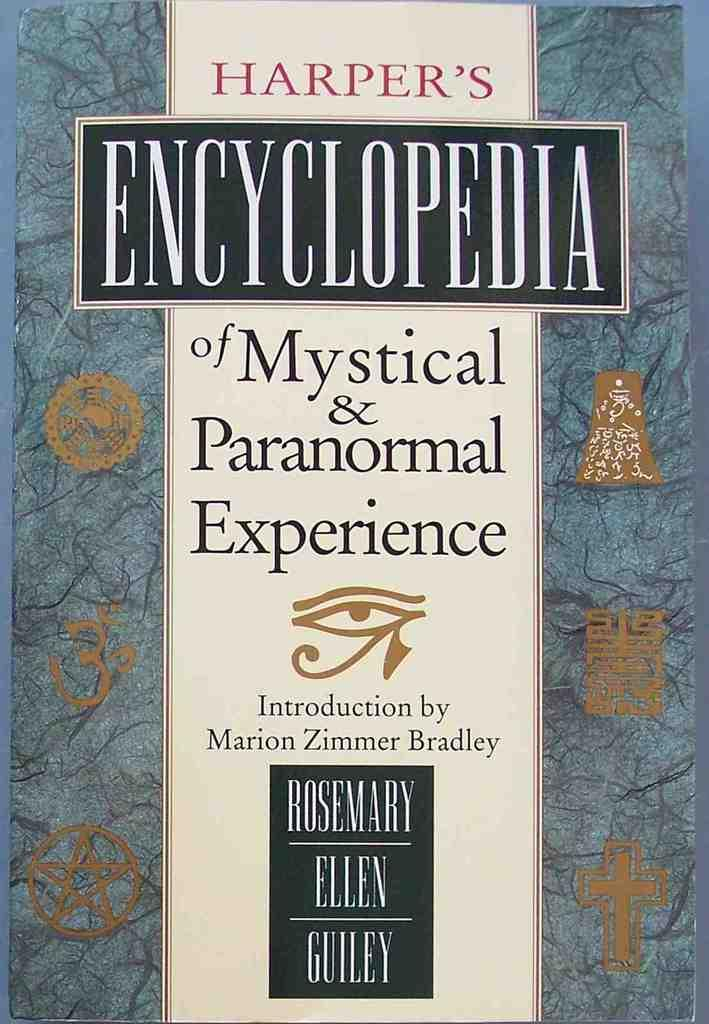<image>
Describe the image concisely. A book called Harper's Encyclopedia of Mystical & Paranormal Experience. 